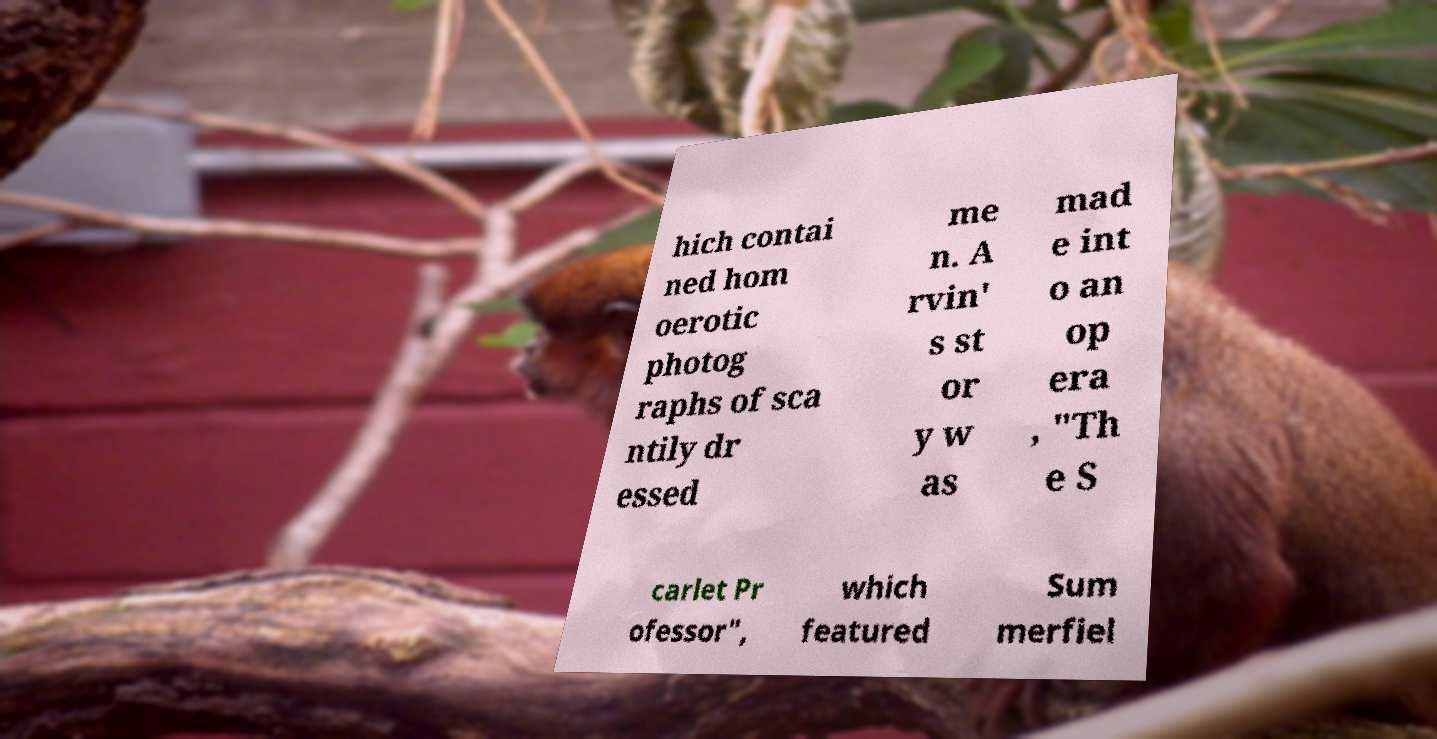Please identify and transcribe the text found in this image. hich contai ned hom oerotic photog raphs of sca ntily dr essed me n. A rvin' s st or y w as mad e int o an op era , "Th e S carlet Pr ofessor", which featured Sum merfiel 